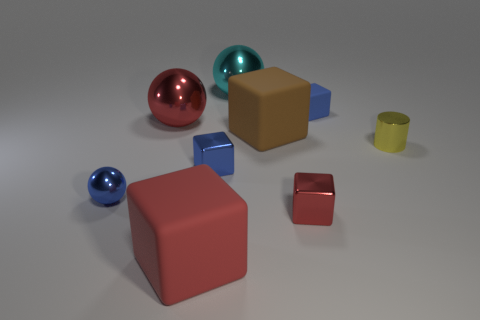Subtract 1 cubes. How many cubes are left? 4 Subtract all brown cubes. How many cubes are left? 4 Subtract all small blue metallic cubes. How many cubes are left? 4 Subtract all yellow cubes. Subtract all red balls. How many cubes are left? 5 Subtract all cylinders. How many objects are left? 8 Add 5 green spheres. How many green spheres exist? 5 Subtract 1 yellow cylinders. How many objects are left? 8 Subtract all yellow rubber cubes. Subtract all tiny blue shiny cubes. How many objects are left? 8 Add 4 brown rubber cubes. How many brown rubber cubes are left? 5 